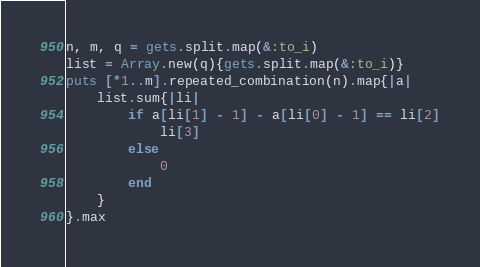<code> <loc_0><loc_0><loc_500><loc_500><_Ruby_>n, m, q = gets.split.map(&:to_i)
list = Array.new(q){gets.split.map(&:to_i)}
puts [*1..m].repeated_combination(n).map{|a|
	list.sum{|li|
		if a[li[1] - 1] - a[li[0] - 1] == li[2]
			li[3]
		else
			0
		end
	}
}.max</code> 